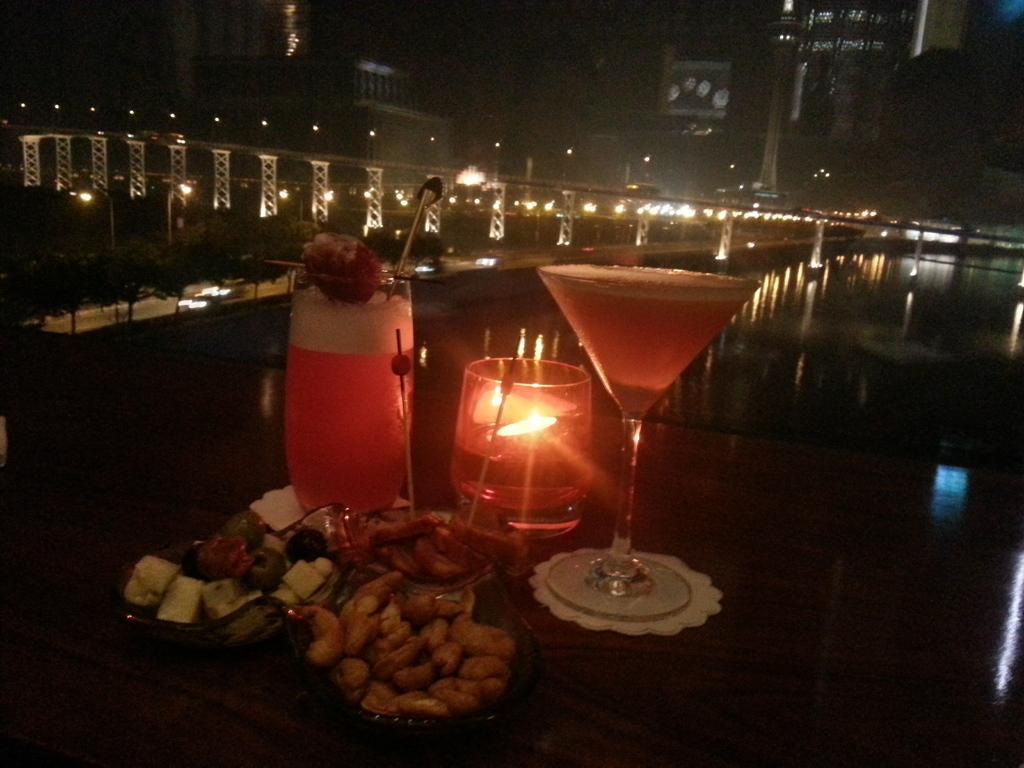Can you describe this image briefly? In this image, on the foreground we can see some sweets, glass on the table and the glass is filled with some liquid. 